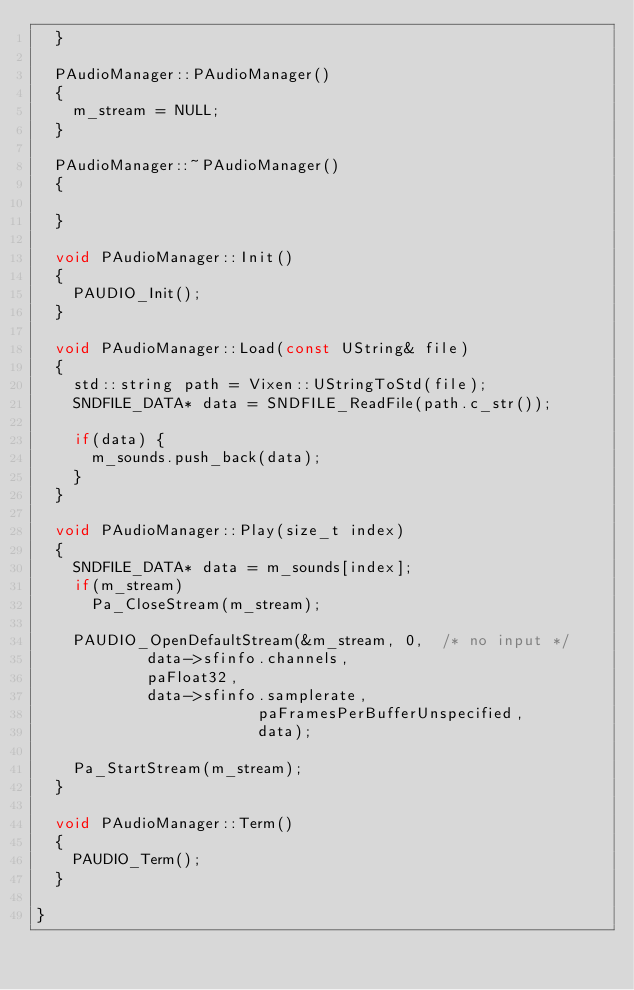<code> <loc_0><loc_0><loc_500><loc_500><_C++_>	}

	PAudioManager::PAudioManager()
	{
		m_stream = NULL;
	}

	PAudioManager::~PAudioManager()
	{

	}

	void PAudioManager::Init()
	{
		PAUDIO_Init();
	}

	void PAudioManager::Load(const UString& file)
	{
		std::string path = Vixen::UStringToStd(file);
		SNDFILE_DATA* data = SNDFILE_ReadFile(path.c_str());

		if(data) {
			m_sounds.push_back(data);
		}
	}

	void PAudioManager::Play(size_t index)
	{
		SNDFILE_DATA* data = m_sounds[index];
		if(m_stream)
			Pa_CloseStream(m_stream);

		PAUDIO_OpenDefaultStream(&m_stream, 0,  /* no input */
						data->sfinfo.channels,
						paFloat32,
						data->sfinfo.samplerate,
                        paFramesPerBufferUnspecified,
                        data);

		Pa_StartStream(m_stream);
	}

	void PAudioManager::Term()
	{
		PAUDIO_Term();
	}

}
</code> 